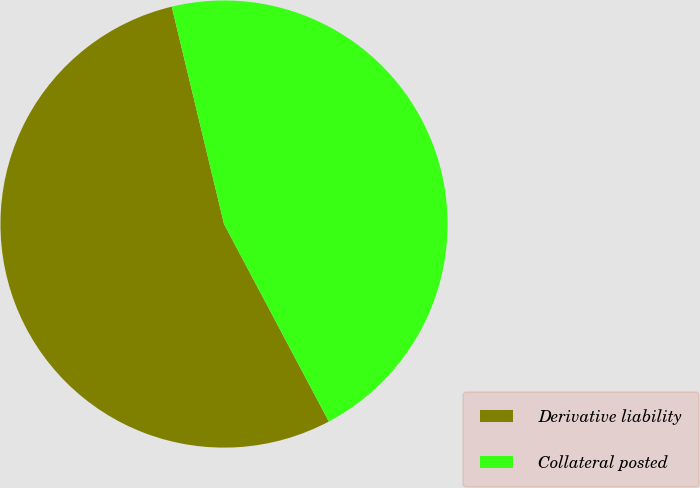<chart> <loc_0><loc_0><loc_500><loc_500><pie_chart><fcel>Derivative liability<fcel>Collateral posted<nl><fcel>54.01%<fcel>45.99%<nl></chart> 